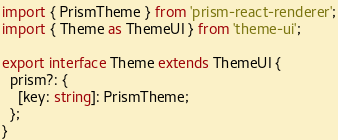Convert code to text. <code><loc_0><loc_0><loc_500><loc_500><_TypeScript_>import { PrismTheme } from 'prism-react-renderer';
import { Theme as ThemeUI } from 'theme-ui';

export interface Theme extends ThemeUI {
  prism?: {
    [key: string]: PrismTheme;
  };
}
</code> 